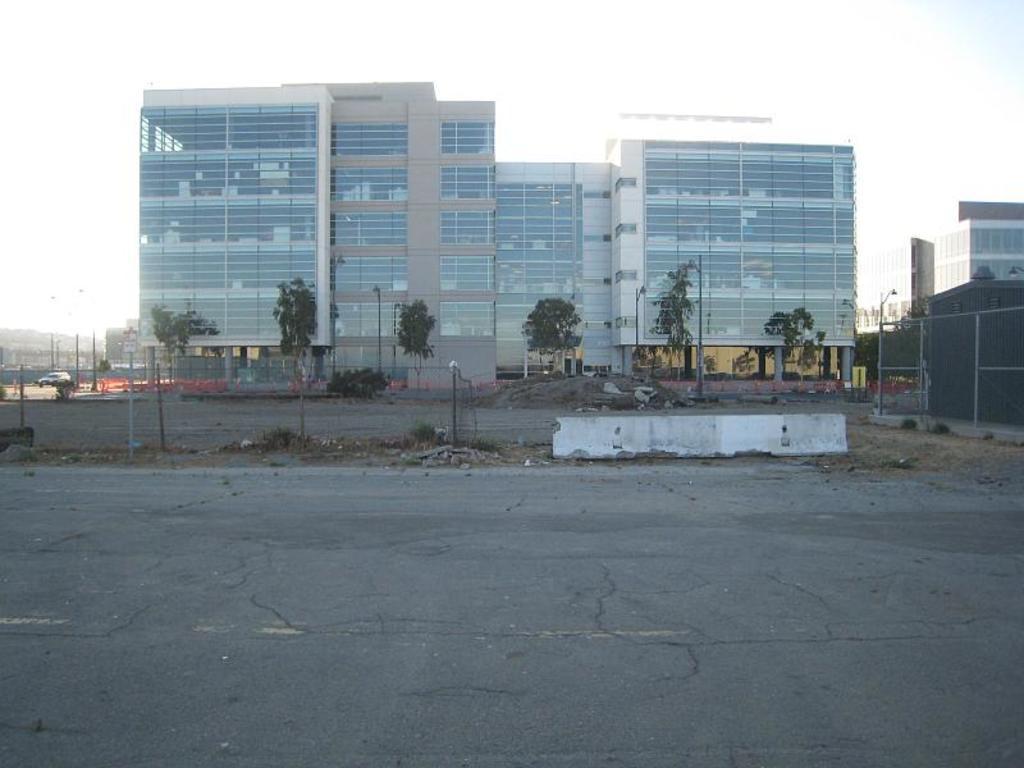In one or two sentences, can you explain what this image depicts? In this image, we can see some trees and buildings. There is a road at the bottom of the image. There are poles in the middle of the image. There is a sky at the top of the image. 